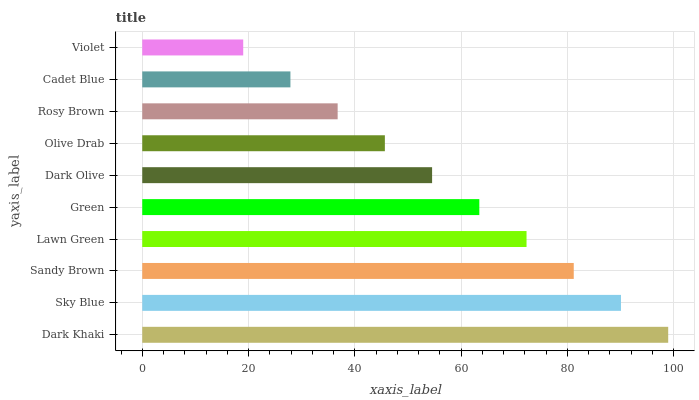Is Violet the minimum?
Answer yes or no. Yes. Is Dark Khaki the maximum?
Answer yes or no. Yes. Is Sky Blue the minimum?
Answer yes or no. No. Is Sky Blue the maximum?
Answer yes or no. No. Is Dark Khaki greater than Sky Blue?
Answer yes or no. Yes. Is Sky Blue less than Dark Khaki?
Answer yes or no. Yes. Is Sky Blue greater than Dark Khaki?
Answer yes or no. No. Is Dark Khaki less than Sky Blue?
Answer yes or no. No. Is Green the high median?
Answer yes or no. Yes. Is Dark Olive the low median?
Answer yes or no. Yes. Is Dark Olive the high median?
Answer yes or no. No. Is Olive Drab the low median?
Answer yes or no. No. 